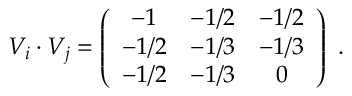Convert formula to latex. <formula><loc_0><loc_0><loc_500><loc_500>V _ { i } \cdot V _ { j } = \left ( \begin{array} { c c c } { - 1 } & { - 1 / 2 } & { - 1 / 2 } \\ { - 1 / 2 } & { - 1 / 3 } & { - 1 / 3 } \\ { - 1 / 2 } & { - 1 / 3 } & { 0 } \end{array} \right ) .</formula> 